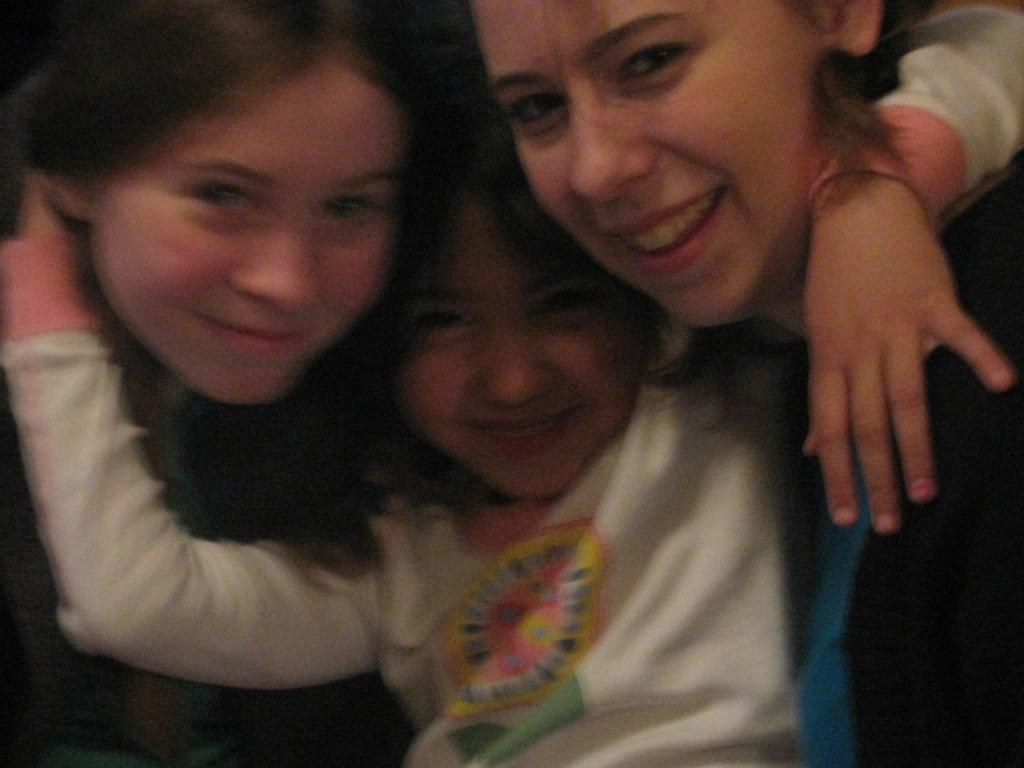What is the main subject of the image? The main subject of the image is a kid. Where is the kid located in the image? The kid is in the middle of the image. What is the kid doing in the image? The kid is holding two women on either side. What is the kid wearing in the image? The kid is wearing a white t-shirt. What type of steam can be seen coming from the tank in the image? There is no steam or tank present in the image; it features a kid holding two women on either side while wearing a white t-shirt. 